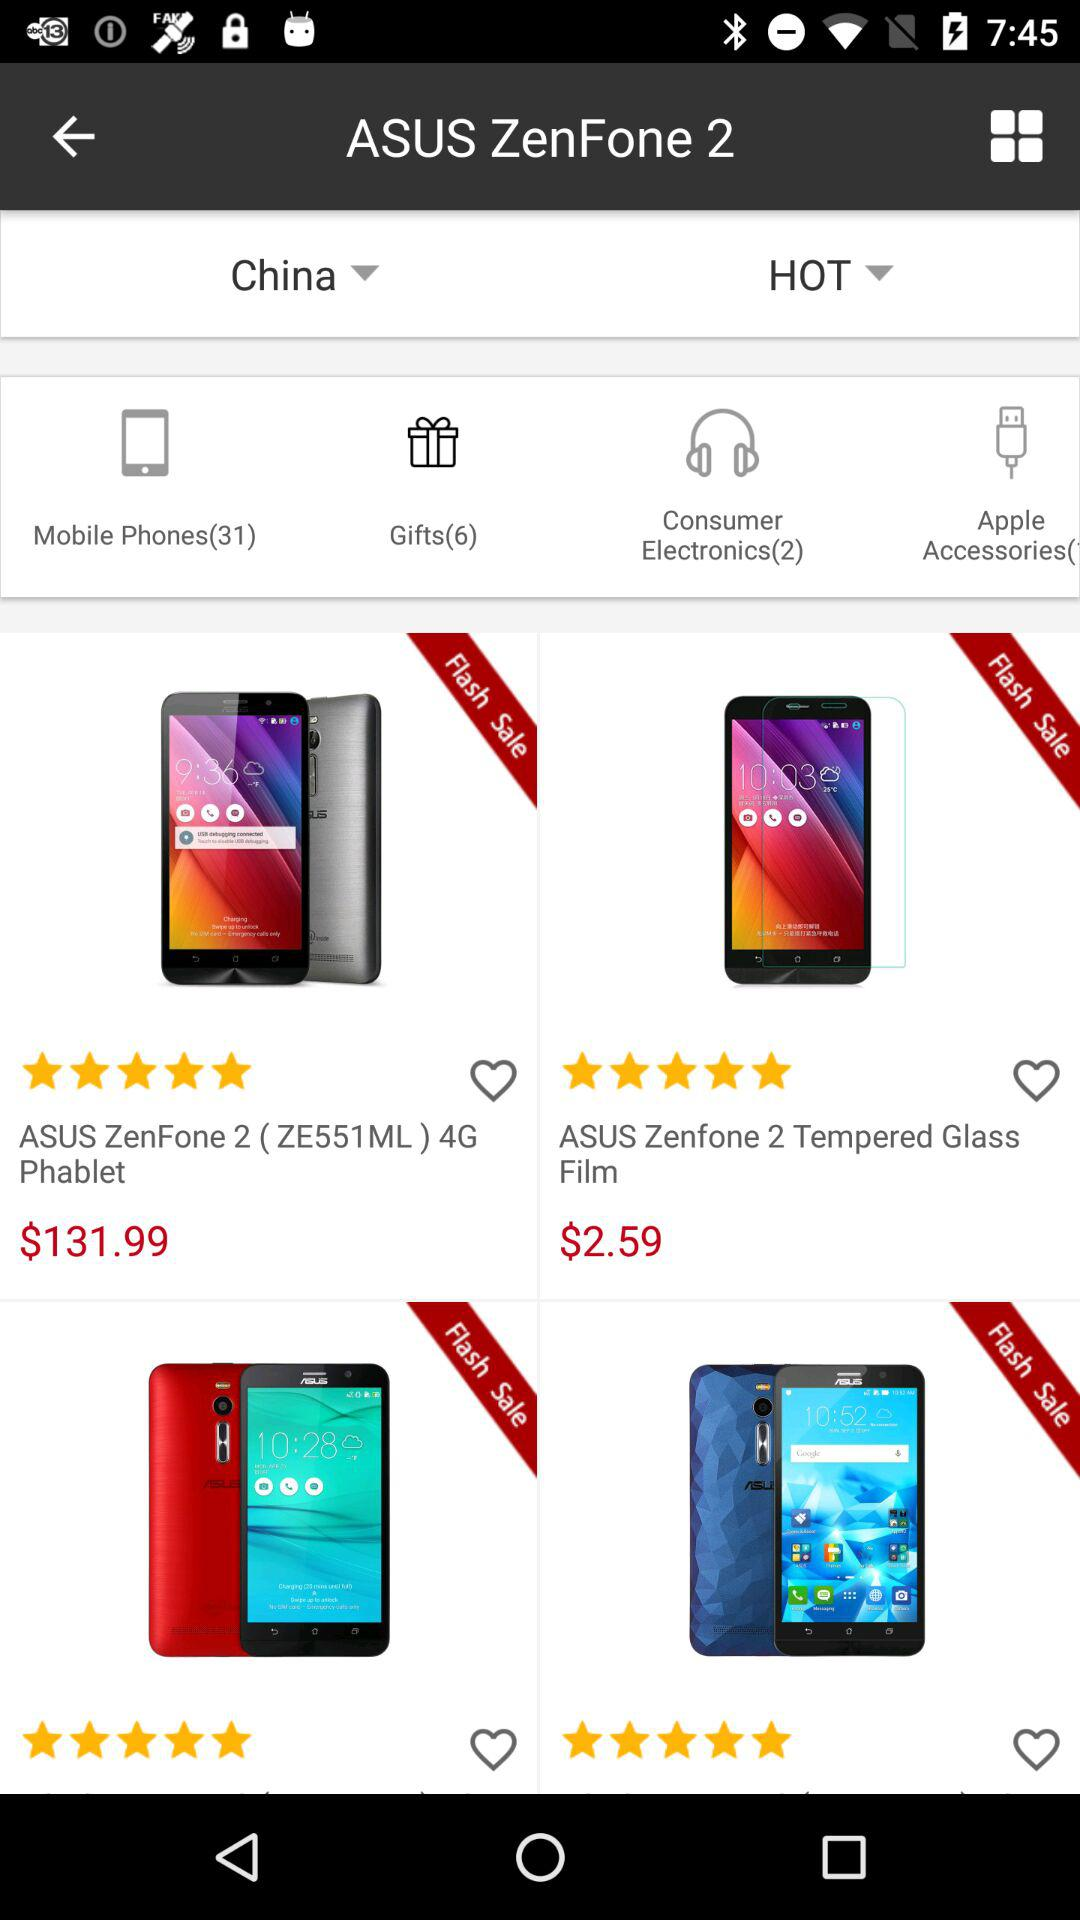What is the cost of the ASUS Zenfone 2 (ZE551ML)? The cost is $131.99. 